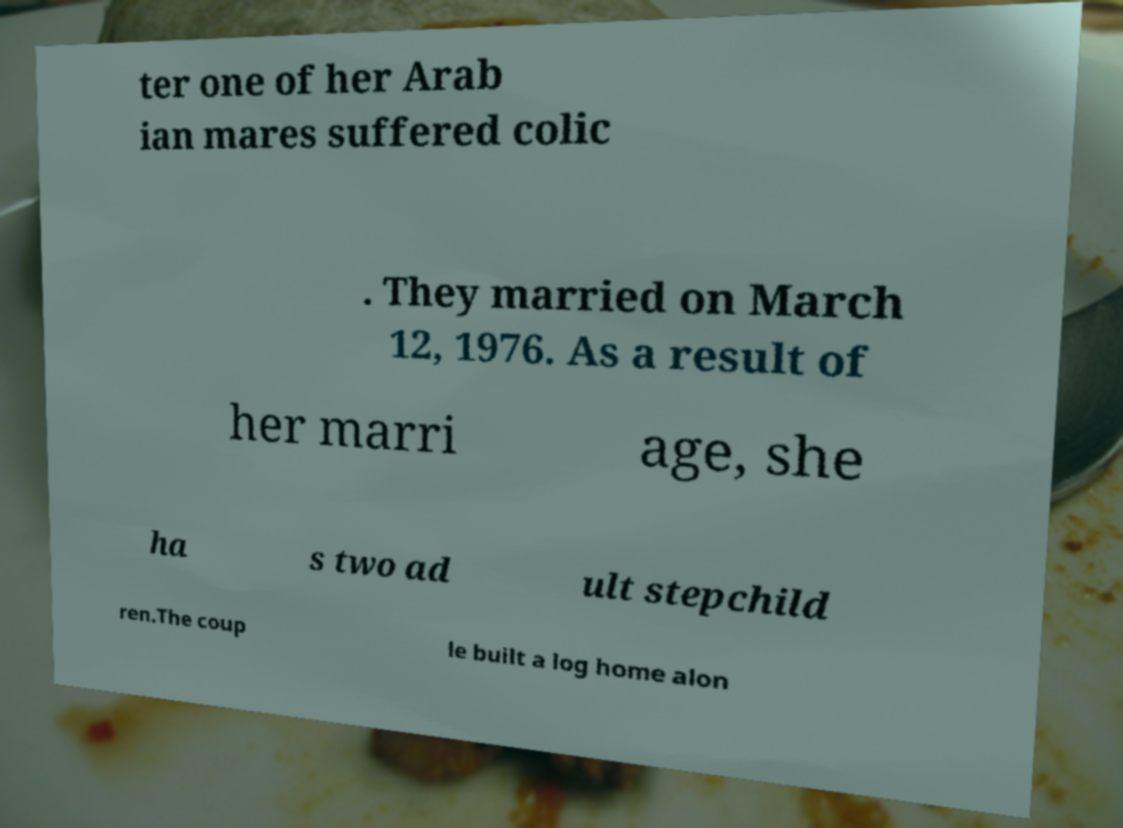Could you assist in decoding the text presented in this image and type it out clearly? ter one of her Arab ian mares suffered colic . They married on March 12, 1976. As a result of her marri age, she ha s two ad ult stepchild ren.The coup le built a log home alon 